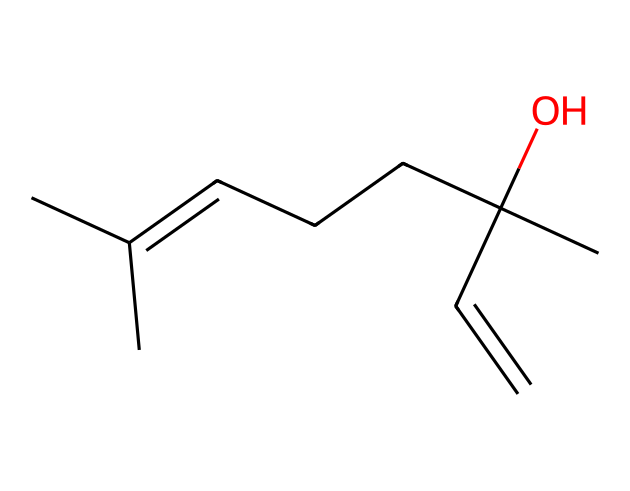What is the functional group present in this structure? The chemical structure shows a hydroxyl group (-OH) attached to a carbon atom, indicating that the compound is classified as an alcohol.
Answer: hydroxyl group How many carbon atoms are in the molecule? By analyzing the SMILES notation, we can count the number of carbon atoms represented. The structure includes 10 carbon atoms in total.
Answer: 10 What type of compound is represented by the SMILES? The presence of the hydroxyl group and a long hydrocarbon chain suggests that this compound is a terpene alcohol, commonly found in essential oils.
Answer: terpene alcohol How many double bonds are in this structure? The SMILES shows two instances of double bonds in the main carbon chain, which are key features of the molecule's unsaturation.
Answer: 2 What specific area of the molecule contributes to its stress-relief properties? The hydroxyl group is often associated with the calming effects of essential oils due to its role in hydrogen bonding and contributing to the overall volatility of the compound.
Answer: hydroxyl group What is the degree of saturation of this molecule? The count of double bonds and the presence of various hydrogen atoms indicate that this molecule is not fully saturated; there are two double bonds, resulting in a degree of unsaturation.
Answer: unsaturated 